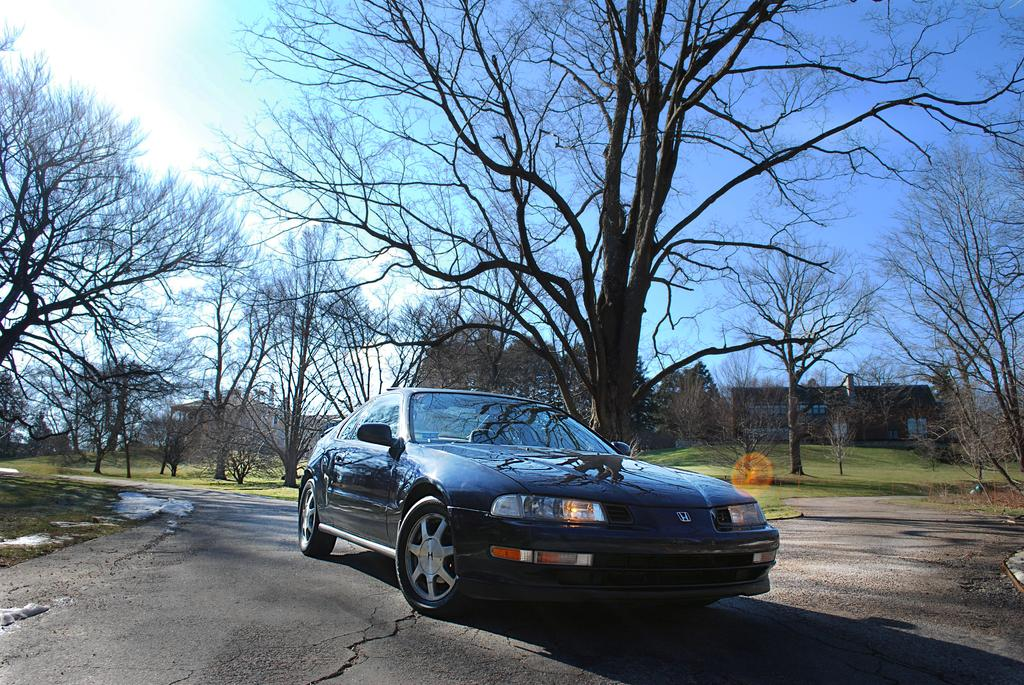What is on the road in the image? There is a vehicle on the road in the image. What type of vegetation can be seen in the image? There is green grass visible in the image. What can be seen in the background of the image? There are trees in the background of the image. What type of structures are present in the image? There are houses in the image. What is visible in the sky in the image? Clouds are visible in the sky in the image. What type of insect is sitting on the roof of the vehicle in the image? There is no insect visible on the roof of the vehicle in the image. How many members of the family are present in the image? The image does not depict a family, so it is not possible to determine the number of family members present. 